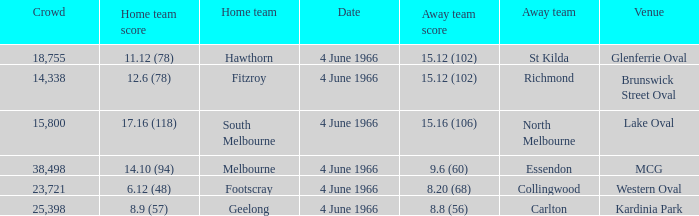What is the largest crowd size that watch a game where the home team scored 12.6 (78)? 14338.0. 